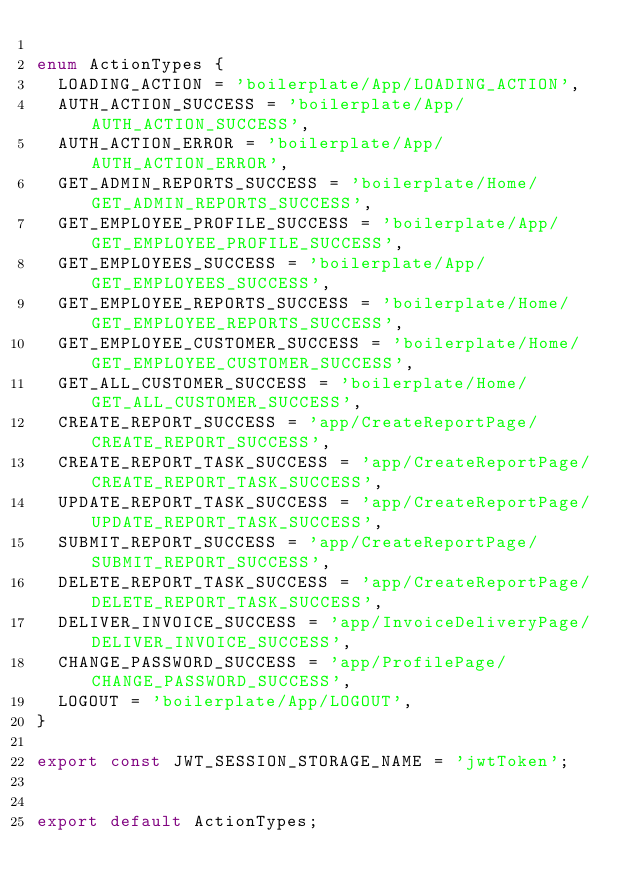<code> <loc_0><loc_0><loc_500><loc_500><_TypeScript_>
enum ActionTypes {
  LOADING_ACTION = 'boilerplate/App/LOADING_ACTION',
  AUTH_ACTION_SUCCESS = 'boilerplate/App/AUTH_ACTION_SUCCESS',
  AUTH_ACTION_ERROR = 'boilerplate/App/AUTH_ACTION_ERROR',
  GET_ADMIN_REPORTS_SUCCESS = 'boilerplate/Home/GET_ADMIN_REPORTS_SUCCESS',
  GET_EMPLOYEE_PROFILE_SUCCESS = 'boilerplate/App/GET_EMPLOYEE_PROFILE_SUCCESS',
  GET_EMPLOYEES_SUCCESS = 'boilerplate/App/GET_EMPLOYEES_SUCCESS',
  GET_EMPLOYEE_REPORTS_SUCCESS = 'boilerplate/Home/GET_EMPLOYEE_REPORTS_SUCCESS',
  GET_EMPLOYEE_CUSTOMER_SUCCESS = 'boilerplate/Home/GET_EMPLOYEE_CUSTOMER_SUCCESS',
  GET_ALL_CUSTOMER_SUCCESS = 'boilerplate/Home/GET_ALL_CUSTOMER_SUCCESS',
  CREATE_REPORT_SUCCESS = 'app/CreateReportPage/CREATE_REPORT_SUCCESS',
  CREATE_REPORT_TASK_SUCCESS = 'app/CreateReportPage/CREATE_REPORT_TASK_SUCCESS',
  UPDATE_REPORT_TASK_SUCCESS = 'app/CreateReportPage/UPDATE_REPORT_TASK_SUCCESS',
  SUBMIT_REPORT_SUCCESS = 'app/CreateReportPage/SUBMIT_REPORT_SUCCESS',
  DELETE_REPORT_TASK_SUCCESS = 'app/CreateReportPage/DELETE_REPORT_TASK_SUCCESS',
  DELIVER_INVOICE_SUCCESS = 'app/InvoiceDeliveryPage/DELIVER_INVOICE_SUCCESS',
  CHANGE_PASSWORD_SUCCESS = 'app/ProfilePage/CHANGE_PASSWORD_SUCCESS',
  LOGOUT = 'boilerplate/App/LOGOUT',
}

export const JWT_SESSION_STORAGE_NAME = 'jwtToken';


export default ActionTypes;
</code> 